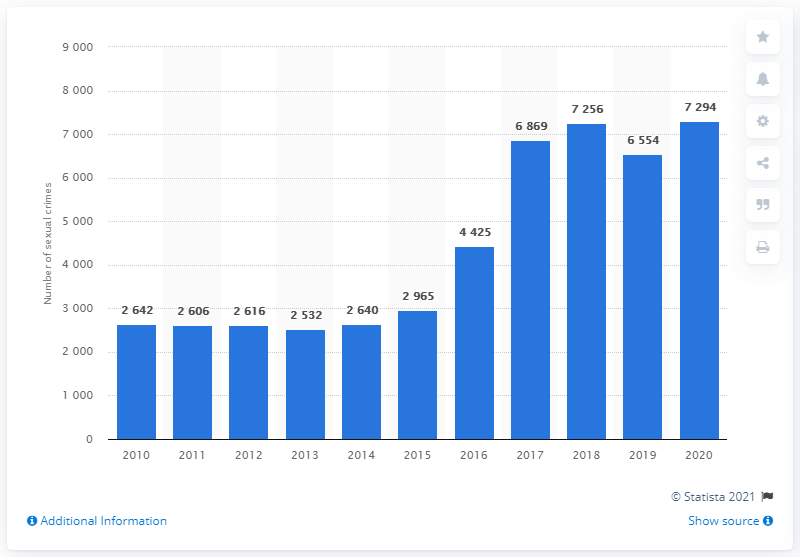How many sexual crimes were reported in Denmark in 2020? In 2020, Denmark reported a total of 7,294 sexual crimes, according to the bar chart presented in the image. This number indicates a concerning upward trend compared to the previous years, reflecting the need for continued awareness and prevention efforts. 